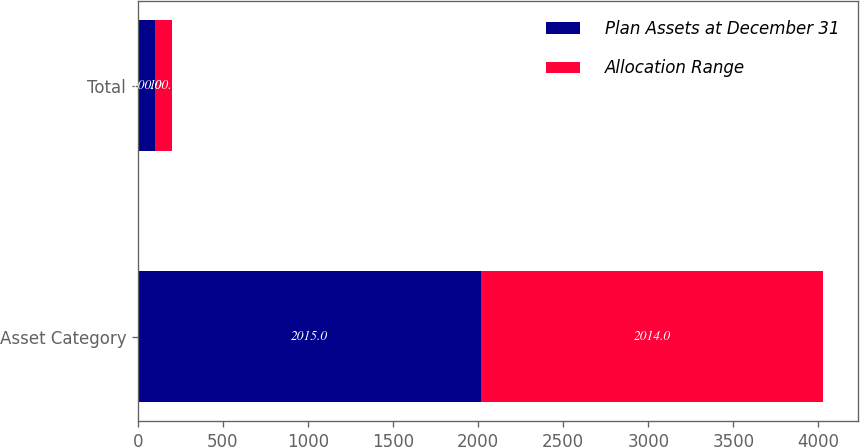<chart> <loc_0><loc_0><loc_500><loc_500><stacked_bar_chart><ecel><fcel>Asset Category<fcel>Total<nl><fcel>Plan Assets at December 31<fcel>2015<fcel>100<nl><fcel>Allocation Range<fcel>2014<fcel>100<nl></chart> 